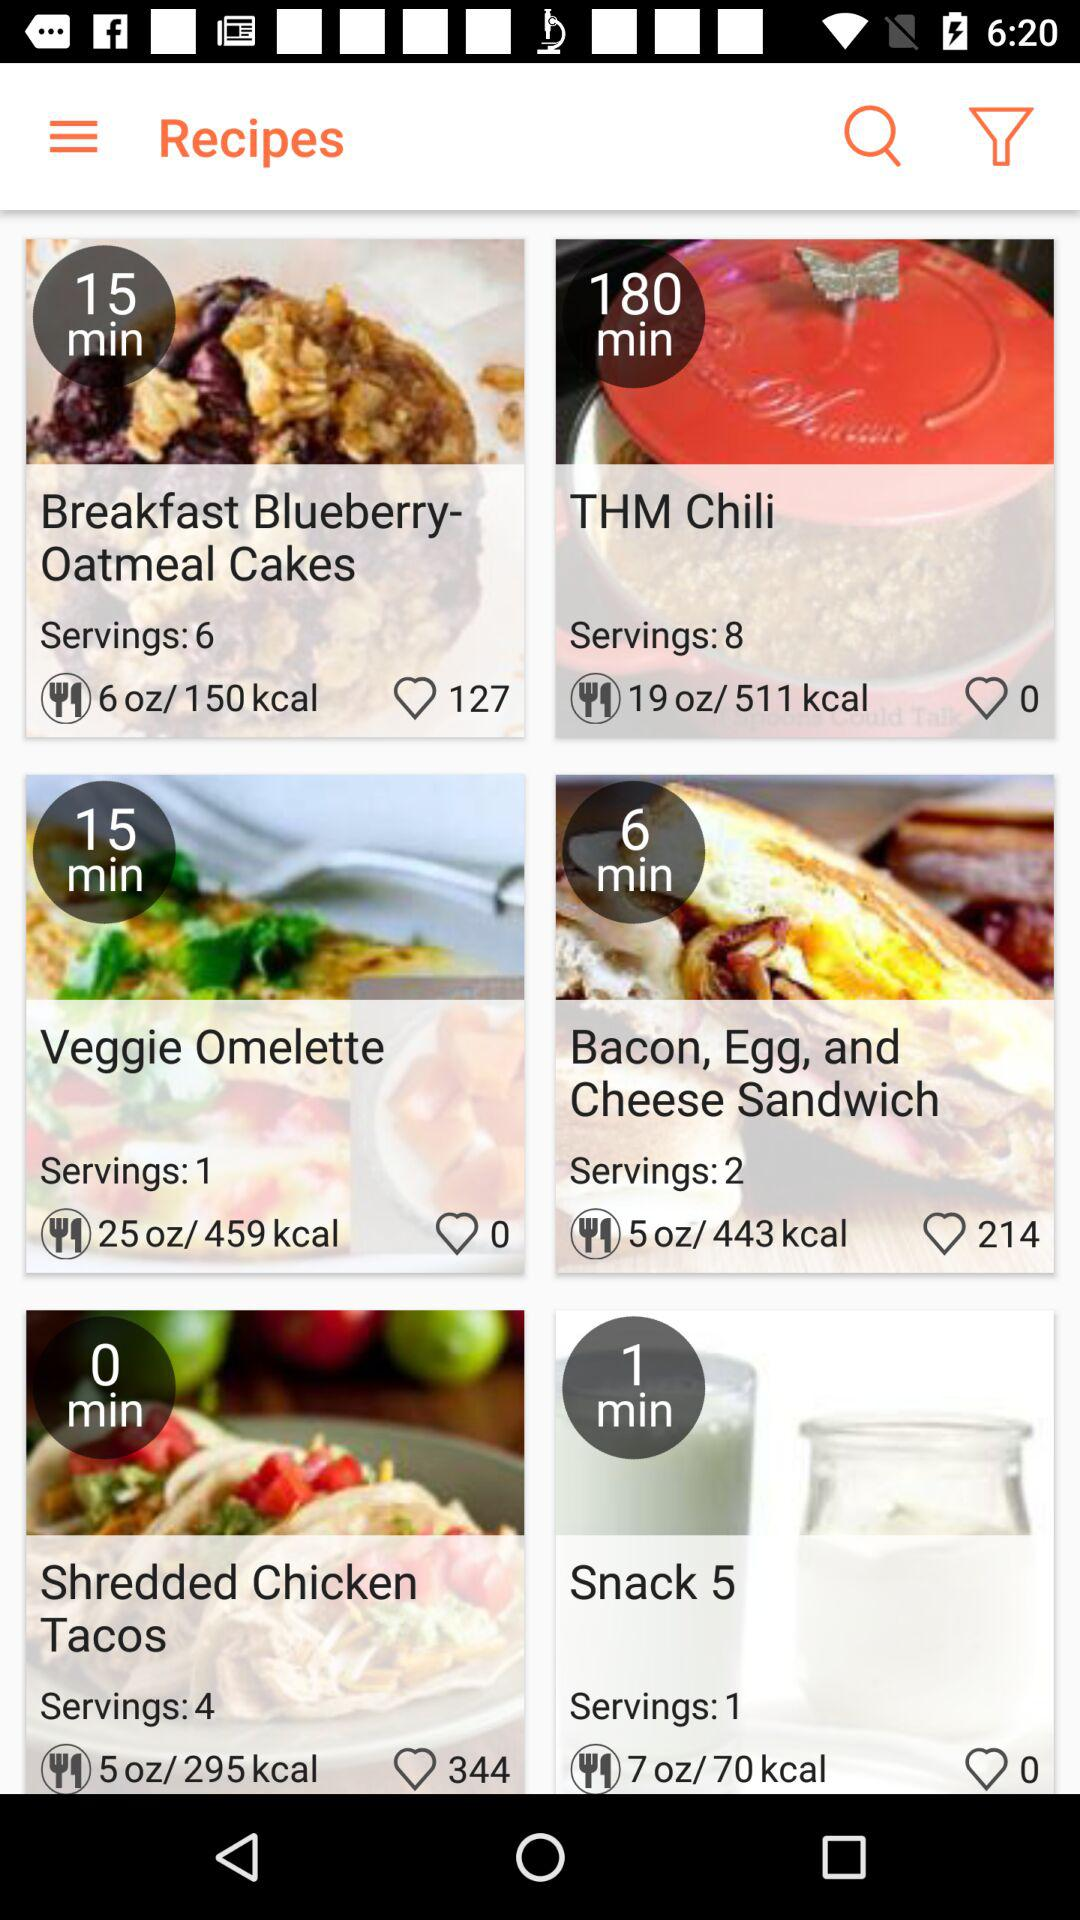How many more minutes does it take to make the thm chili than the veggie omelette?
Answer the question using a single word or phrase. 165 